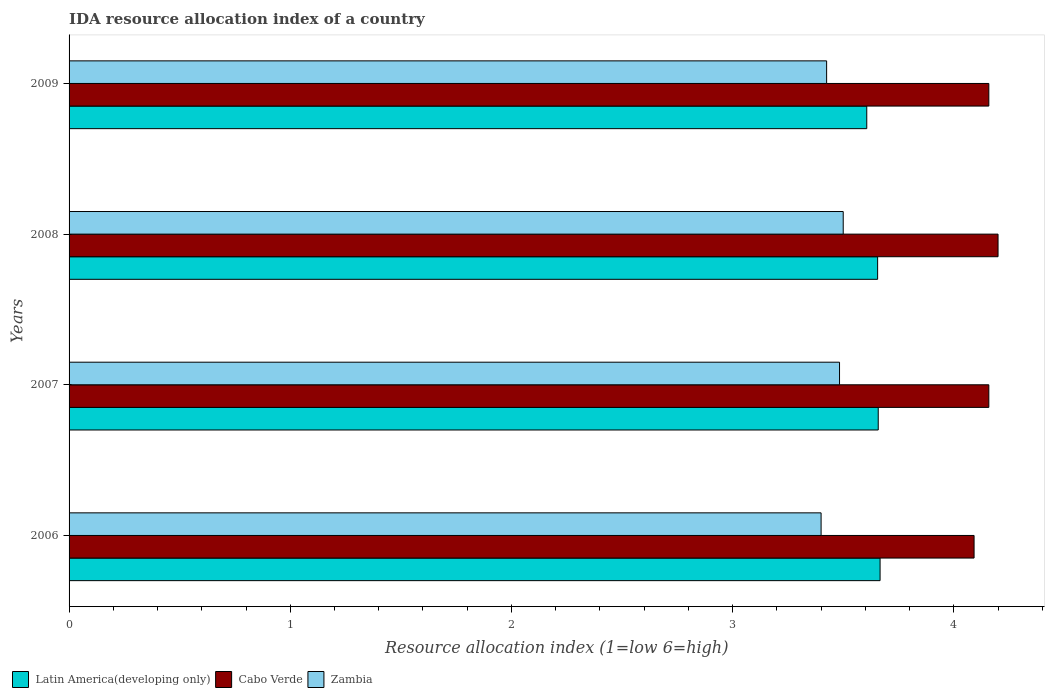How many groups of bars are there?
Provide a short and direct response. 4. Are the number of bars on each tick of the Y-axis equal?
Keep it short and to the point. Yes. In how many cases, is the number of bars for a given year not equal to the number of legend labels?
Keep it short and to the point. 0. What is the IDA resource allocation index in Cabo Verde in 2008?
Your response must be concise. 4.2. Across all years, what is the maximum IDA resource allocation index in Zambia?
Your answer should be very brief. 3.5. Across all years, what is the minimum IDA resource allocation index in Latin America(developing only)?
Provide a succinct answer. 3.61. In which year was the IDA resource allocation index in Cabo Verde minimum?
Provide a short and direct response. 2006. What is the total IDA resource allocation index in Cabo Verde in the graph?
Your answer should be compact. 16.61. What is the difference between the IDA resource allocation index in Latin America(developing only) in 2007 and that in 2008?
Keep it short and to the point. 0. What is the difference between the IDA resource allocation index in Cabo Verde in 2006 and the IDA resource allocation index in Zambia in 2009?
Offer a terse response. 0.67. What is the average IDA resource allocation index in Cabo Verde per year?
Offer a very short reply. 4.15. In the year 2009, what is the difference between the IDA resource allocation index in Latin America(developing only) and IDA resource allocation index in Zambia?
Keep it short and to the point. 0.18. In how many years, is the IDA resource allocation index in Zambia greater than 3 ?
Your response must be concise. 4. What is the ratio of the IDA resource allocation index in Zambia in 2006 to that in 2007?
Your answer should be very brief. 0.98. Is the IDA resource allocation index in Cabo Verde in 2008 less than that in 2009?
Give a very brief answer. No. What is the difference between the highest and the second highest IDA resource allocation index in Latin America(developing only)?
Keep it short and to the point. 0.01. What is the difference between the highest and the lowest IDA resource allocation index in Cabo Verde?
Provide a short and direct response. 0.11. In how many years, is the IDA resource allocation index in Zambia greater than the average IDA resource allocation index in Zambia taken over all years?
Make the answer very short. 2. Is the sum of the IDA resource allocation index in Latin America(developing only) in 2007 and 2009 greater than the maximum IDA resource allocation index in Cabo Verde across all years?
Give a very brief answer. Yes. What does the 1st bar from the top in 2006 represents?
Ensure brevity in your answer.  Zambia. What does the 3rd bar from the bottom in 2007 represents?
Provide a succinct answer. Zambia. Is it the case that in every year, the sum of the IDA resource allocation index in Latin America(developing only) and IDA resource allocation index in Zambia is greater than the IDA resource allocation index in Cabo Verde?
Offer a very short reply. Yes. How many bars are there?
Your answer should be compact. 12. Does the graph contain any zero values?
Offer a very short reply. No. Where does the legend appear in the graph?
Make the answer very short. Bottom left. How are the legend labels stacked?
Provide a short and direct response. Horizontal. What is the title of the graph?
Your answer should be very brief. IDA resource allocation index of a country. Does "Kuwait" appear as one of the legend labels in the graph?
Your response must be concise. No. What is the label or title of the X-axis?
Your answer should be compact. Resource allocation index (1=low 6=high). What is the label or title of the Y-axis?
Give a very brief answer. Years. What is the Resource allocation index (1=low 6=high) in Latin America(developing only) in 2006?
Offer a terse response. 3.67. What is the Resource allocation index (1=low 6=high) in Cabo Verde in 2006?
Keep it short and to the point. 4.09. What is the Resource allocation index (1=low 6=high) of Zambia in 2006?
Ensure brevity in your answer.  3.4. What is the Resource allocation index (1=low 6=high) of Latin America(developing only) in 2007?
Provide a short and direct response. 3.66. What is the Resource allocation index (1=low 6=high) in Cabo Verde in 2007?
Ensure brevity in your answer.  4.16. What is the Resource allocation index (1=low 6=high) of Zambia in 2007?
Offer a very short reply. 3.48. What is the Resource allocation index (1=low 6=high) in Latin America(developing only) in 2008?
Make the answer very short. 3.66. What is the Resource allocation index (1=low 6=high) of Zambia in 2008?
Provide a short and direct response. 3.5. What is the Resource allocation index (1=low 6=high) of Latin America(developing only) in 2009?
Your answer should be very brief. 3.61. What is the Resource allocation index (1=low 6=high) of Cabo Verde in 2009?
Provide a succinct answer. 4.16. What is the Resource allocation index (1=low 6=high) of Zambia in 2009?
Offer a terse response. 3.42. Across all years, what is the maximum Resource allocation index (1=low 6=high) in Latin America(developing only)?
Your answer should be compact. 3.67. Across all years, what is the maximum Resource allocation index (1=low 6=high) in Cabo Verde?
Make the answer very short. 4.2. Across all years, what is the minimum Resource allocation index (1=low 6=high) of Latin America(developing only)?
Your answer should be very brief. 3.61. Across all years, what is the minimum Resource allocation index (1=low 6=high) in Cabo Verde?
Give a very brief answer. 4.09. Across all years, what is the minimum Resource allocation index (1=low 6=high) of Zambia?
Ensure brevity in your answer.  3.4. What is the total Resource allocation index (1=low 6=high) in Latin America(developing only) in the graph?
Keep it short and to the point. 14.59. What is the total Resource allocation index (1=low 6=high) of Cabo Verde in the graph?
Keep it short and to the point. 16.61. What is the total Resource allocation index (1=low 6=high) of Zambia in the graph?
Give a very brief answer. 13.81. What is the difference between the Resource allocation index (1=low 6=high) of Latin America(developing only) in 2006 and that in 2007?
Provide a succinct answer. 0.01. What is the difference between the Resource allocation index (1=low 6=high) in Cabo Verde in 2006 and that in 2007?
Your response must be concise. -0.07. What is the difference between the Resource allocation index (1=low 6=high) in Zambia in 2006 and that in 2007?
Keep it short and to the point. -0.08. What is the difference between the Resource allocation index (1=low 6=high) in Latin America(developing only) in 2006 and that in 2008?
Make the answer very short. 0.01. What is the difference between the Resource allocation index (1=low 6=high) in Cabo Verde in 2006 and that in 2008?
Ensure brevity in your answer.  -0.11. What is the difference between the Resource allocation index (1=low 6=high) of Zambia in 2006 and that in 2008?
Your answer should be very brief. -0.1. What is the difference between the Resource allocation index (1=low 6=high) of Latin America(developing only) in 2006 and that in 2009?
Make the answer very short. 0.06. What is the difference between the Resource allocation index (1=low 6=high) in Cabo Verde in 2006 and that in 2009?
Ensure brevity in your answer.  -0.07. What is the difference between the Resource allocation index (1=low 6=high) in Zambia in 2006 and that in 2009?
Offer a very short reply. -0.03. What is the difference between the Resource allocation index (1=low 6=high) of Latin America(developing only) in 2007 and that in 2008?
Offer a terse response. 0. What is the difference between the Resource allocation index (1=low 6=high) of Cabo Verde in 2007 and that in 2008?
Make the answer very short. -0.04. What is the difference between the Resource allocation index (1=low 6=high) of Zambia in 2007 and that in 2008?
Make the answer very short. -0.02. What is the difference between the Resource allocation index (1=low 6=high) in Latin America(developing only) in 2007 and that in 2009?
Your answer should be compact. 0.05. What is the difference between the Resource allocation index (1=low 6=high) of Cabo Verde in 2007 and that in 2009?
Make the answer very short. 0. What is the difference between the Resource allocation index (1=low 6=high) of Zambia in 2007 and that in 2009?
Give a very brief answer. 0.06. What is the difference between the Resource allocation index (1=low 6=high) in Latin America(developing only) in 2008 and that in 2009?
Provide a short and direct response. 0.05. What is the difference between the Resource allocation index (1=low 6=high) of Cabo Verde in 2008 and that in 2009?
Keep it short and to the point. 0.04. What is the difference between the Resource allocation index (1=low 6=high) of Zambia in 2008 and that in 2009?
Make the answer very short. 0.07. What is the difference between the Resource allocation index (1=low 6=high) of Latin America(developing only) in 2006 and the Resource allocation index (1=low 6=high) of Cabo Verde in 2007?
Offer a terse response. -0.49. What is the difference between the Resource allocation index (1=low 6=high) in Latin America(developing only) in 2006 and the Resource allocation index (1=low 6=high) in Zambia in 2007?
Offer a terse response. 0.18. What is the difference between the Resource allocation index (1=low 6=high) of Cabo Verde in 2006 and the Resource allocation index (1=low 6=high) of Zambia in 2007?
Your answer should be compact. 0.61. What is the difference between the Resource allocation index (1=low 6=high) of Latin America(developing only) in 2006 and the Resource allocation index (1=low 6=high) of Cabo Verde in 2008?
Provide a short and direct response. -0.53. What is the difference between the Resource allocation index (1=low 6=high) of Latin America(developing only) in 2006 and the Resource allocation index (1=low 6=high) of Zambia in 2008?
Give a very brief answer. 0.17. What is the difference between the Resource allocation index (1=low 6=high) in Cabo Verde in 2006 and the Resource allocation index (1=low 6=high) in Zambia in 2008?
Make the answer very short. 0.59. What is the difference between the Resource allocation index (1=low 6=high) in Latin America(developing only) in 2006 and the Resource allocation index (1=low 6=high) in Cabo Verde in 2009?
Offer a very short reply. -0.49. What is the difference between the Resource allocation index (1=low 6=high) in Latin America(developing only) in 2006 and the Resource allocation index (1=low 6=high) in Zambia in 2009?
Your answer should be very brief. 0.24. What is the difference between the Resource allocation index (1=low 6=high) of Latin America(developing only) in 2007 and the Resource allocation index (1=low 6=high) of Cabo Verde in 2008?
Give a very brief answer. -0.54. What is the difference between the Resource allocation index (1=low 6=high) in Latin America(developing only) in 2007 and the Resource allocation index (1=low 6=high) in Zambia in 2008?
Keep it short and to the point. 0.16. What is the difference between the Resource allocation index (1=low 6=high) of Cabo Verde in 2007 and the Resource allocation index (1=low 6=high) of Zambia in 2008?
Your answer should be very brief. 0.66. What is the difference between the Resource allocation index (1=low 6=high) in Latin America(developing only) in 2007 and the Resource allocation index (1=low 6=high) in Cabo Verde in 2009?
Keep it short and to the point. -0.5. What is the difference between the Resource allocation index (1=low 6=high) in Latin America(developing only) in 2007 and the Resource allocation index (1=low 6=high) in Zambia in 2009?
Your answer should be compact. 0.23. What is the difference between the Resource allocation index (1=low 6=high) of Cabo Verde in 2007 and the Resource allocation index (1=low 6=high) of Zambia in 2009?
Provide a succinct answer. 0.73. What is the difference between the Resource allocation index (1=low 6=high) in Latin America(developing only) in 2008 and the Resource allocation index (1=low 6=high) in Cabo Verde in 2009?
Your answer should be compact. -0.5. What is the difference between the Resource allocation index (1=low 6=high) in Latin America(developing only) in 2008 and the Resource allocation index (1=low 6=high) in Zambia in 2009?
Keep it short and to the point. 0.23. What is the difference between the Resource allocation index (1=low 6=high) of Cabo Verde in 2008 and the Resource allocation index (1=low 6=high) of Zambia in 2009?
Offer a very short reply. 0.78. What is the average Resource allocation index (1=low 6=high) in Latin America(developing only) per year?
Provide a succinct answer. 3.65. What is the average Resource allocation index (1=low 6=high) of Cabo Verde per year?
Your response must be concise. 4.15. What is the average Resource allocation index (1=low 6=high) in Zambia per year?
Your answer should be very brief. 3.45. In the year 2006, what is the difference between the Resource allocation index (1=low 6=high) of Latin America(developing only) and Resource allocation index (1=low 6=high) of Cabo Verde?
Ensure brevity in your answer.  -0.42. In the year 2006, what is the difference between the Resource allocation index (1=low 6=high) of Latin America(developing only) and Resource allocation index (1=low 6=high) of Zambia?
Offer a terse response. 0.27. In the year 2006, what is the difference between the Resource allocation index (1=low 6=high) in Cabo Verde and Resource allocation index (1=low 6=high) in Zambia?
Your response must be concise. 0.69. In the year 2007, what is the difference between the Resource allocation index (1=low 6=high) in Latin America(developing only) and Resource allocation index (1=low 6=high) in Zambia?
Your answer should be very brief. 0.17. In the year 2007, what is the difference between the Resource allocation index (1=low 6=high) in Cabo Verde and Resource allocation index (1=low 6=high) in Zambia?
Offer a terse response. 0.68. In the year 2008, what is the difference between the Resource allocation index (1=low 6=high) of Latin America(developing only) and Resource allocation index (1=low 6=high) of Cabo Verde?
Give a very brief answer. -0.54. In the year 2008, what is the difference between the Resource allocation index (1=low 6=high) of Latin America(developing only) and Resource allocation index (1=low 6=high) of Zambia?
Provide a short and direct response. 0.16. In the year 2009, what is the difference between the Resource allocation index (1=low 6=high) of Latin America(developing only) and Resource allocation index (1=low 6=high) of Cabo Verde?
Offer a terse response. -0.55. In the year 2009, what is the difference between the Resource allocation index (1=low 6=high) in Latin America(developing only) and Resource allocation index (1=low 6=high) in Zambia?
Make the answer very short. 0.18. In the year 2009, what is the difference between the Resource allocation index (1=low 6=high) of Cabo Verde and Resource allocation index (1=low 6=high) of Zambia?
Your response must be concise. 0.73. What is the ratio of the Resource allocation index (1=low 6=high) of Zambia in 2006 to that in 2007?
Your response must be concise. 0.98. What is the ratio of the Resource allocation index (1=low 6=high) in Latin America(developing only) in 2006 to that in 2008?
Your answer should be compact. 1. What is the ratio of the Resource allocation index (1=low 6=high) of Cabo Verde in 2006 to that in 2008?
Give a very brief answer. 0.97. What is the ratio of the Resource allocation index (1=low 6=high) in Zambia in 2006 to that in 2008?
Your answer should be compact. 0.97. What is the ratio of the Resource allocation index (1=low 6=high) in Latin America(developing only) in 2006 to that in 2009?
Make the answer very short. 1.02. What is the ratio of the Resource allocation index (1=low 6=high) of Latin America(developing only) in 2007 to that in 2008?
Provide a short and direct response. 1. What is the ratio of the Resource allocation index (1=low 6=high) in Latin America(developing only) in 2007 to that in 2009?
Your response must be concise. 1.01. What is the ratio of the Resource allocation index (1=low 6=high) in Cabo Verde in 2007 to that in 2009?
Provide a short and direct response. 1. What is the ratio of the Resource allocation index (1=low 6=high) in Zambia in 2007 to that in 2009?
Give a very brief answer. 1.02. What is the ratio of the Resource allocation index (1=low 6=high) in Latin America(developing only) in 2008 to that in 2009?
Provide a short and direct response. 1.01. What is the ratio of the Resource allocation index (1=low 6=high) of Zambia in 2008 to that in 2009?
Your answer should be very brief. 1.02. What is the difference between the highest and the second highest Resource allocation index (1=low 6=high) in Latin America(developing only)?
Keep it short and to the point. 0.01. What is the difference between the highest and the second highest Resource allocation index (1=low 6=high) in Cabo Verde?
Offer a very short reply. 0.04. What is the difference between the highest and the second highest Resource allocation index (1=low 6=high) in Zambia?
Provide a short and direct response. 0.02. What is the difference between the highest and the lowest Resource allocation index (1=low 6=high) of Latin America(developing only)?
Your answer should be compact. 0.06. What is the difference between the highest and the lowest Resource allocation index (1=low 6=high) of Cabo Verde?
Keep it short and to the point. 0.11. What is the difference between the highest and the lowest Resource allocation index (1=low 6=high) of Zambia?
Your answer should be compact. 0.1. 